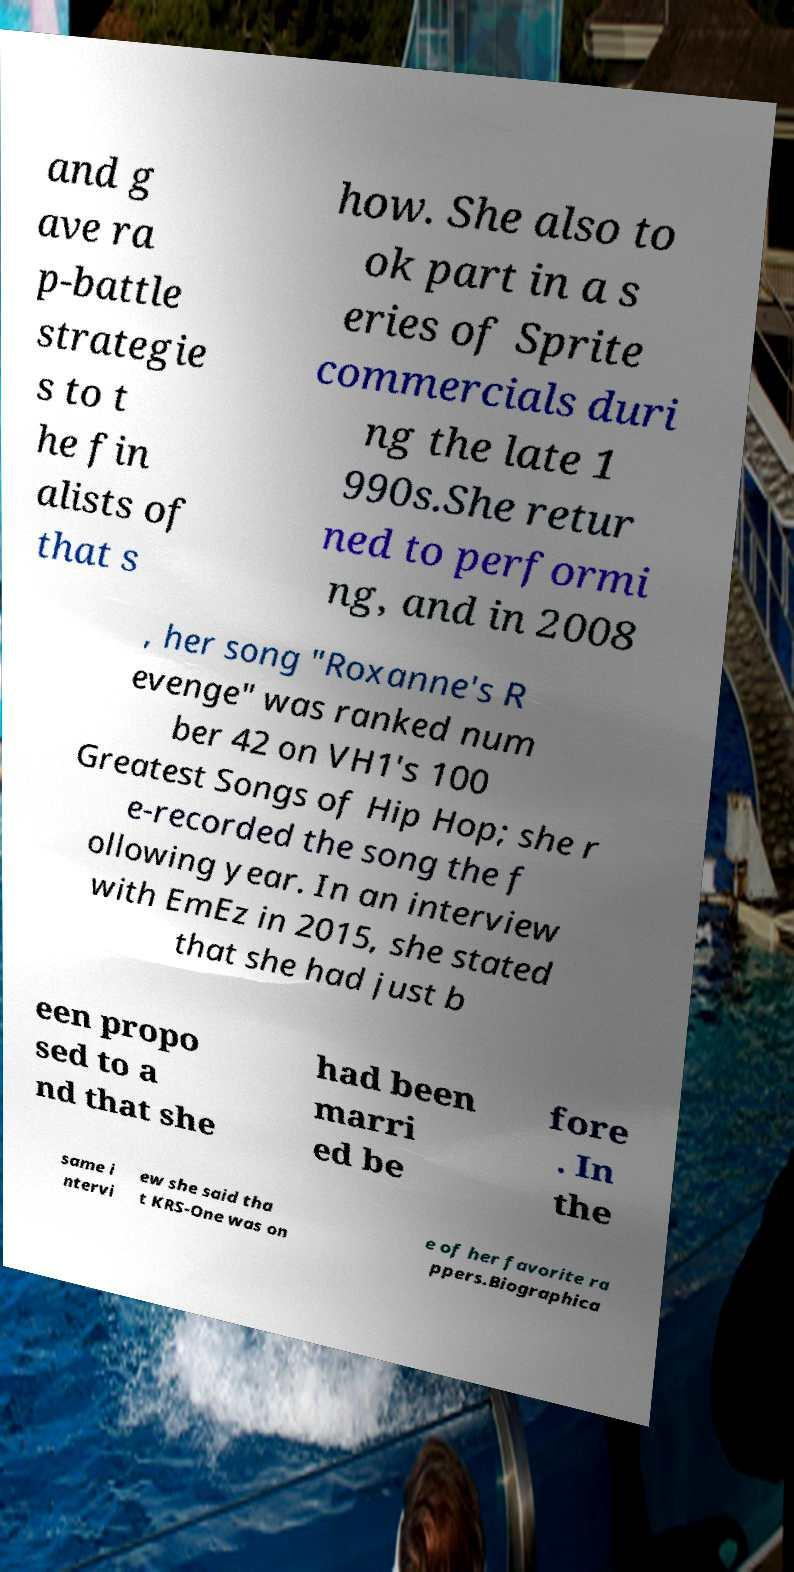Can you accurately transcribe the text from the provided image for me? and g ave ra p-battle strategie s to t he fin alists of that s how. She also to ok part in a s eries of Sprite commercials duri ng the late 1 990s.She retur ned to performi ng, and in 2008 , her song "Roxanne's R evenge" was ranked num ber 42 on VH1's 100 Greatest Songs of Hip Hop; she r e-recorded the song the f ollowing year. In an interview with EmEz in 2015, she stated that she had just b een propo sed to a nd that she had been marri ed be fore . In the same i ntervi ew she said tha t KRS-One was on e of her favorite ra ppers.Biographica 